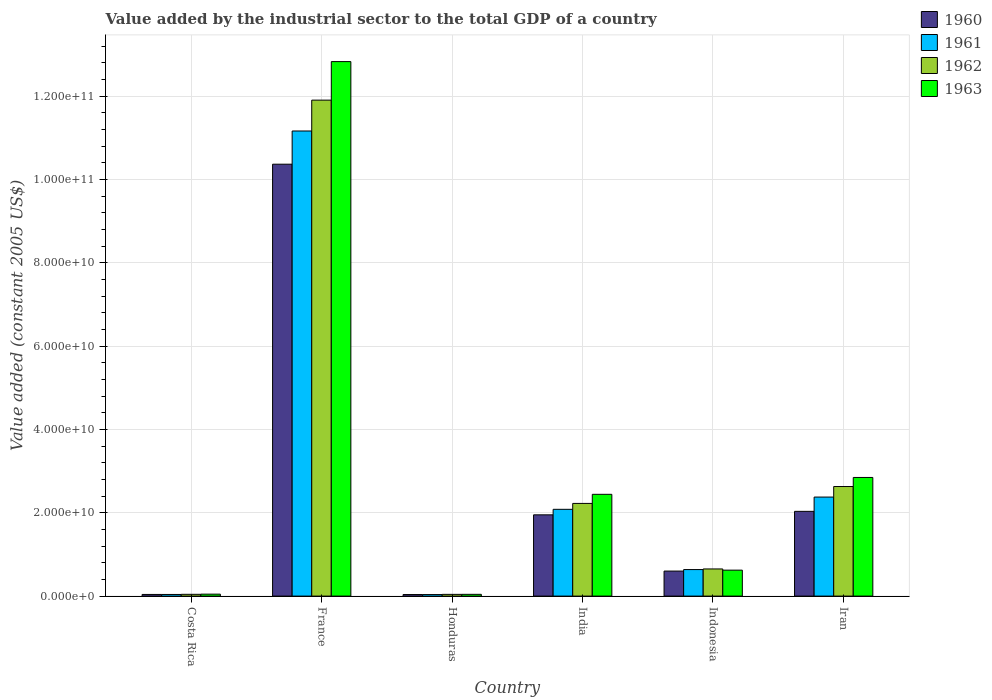How many groups of bars are there?
Make the answer very short. 6. Are the number of bars on each tick of the X-axis equal?
Keep it short and to the point. Yes. How many bars are there on the 6th tick from the left?
Your answer should be very brief. 4. What is the label of the 3rd group of bars from the left?
Give a very brief answer. Honduras. In how many cases, is the number of bars for a given country not equal to the number of legend labels?
Provide a succinct answer. 0. What is the value added by the industrial sector in 1961 in Honduras?
Offer a terse response. 3.66e+08. Across all countries, what is the maximum value added by the industrial sector in 1961?
Your answer should be very brief. 1.12e+11. Across all countries, what is the minimum value added by the industrial sector in 1960?
Ensure brevity in your answer.  3.75e+08. In which country was the value added by the industrial sector in 1963 minimum?
Provide a short and direct response. Honduras. What is the total value added by the industrial sector in 1963 in the graph?
Offer a terse response. 1.88e+11. What is the difference between the value added by the industrial sector in 1960 in Indonesia and that in Iran?
Ensure brevity in your answer.  -1.43e+1. What is the difference between the value added by the industrial sector in 1961 in Indonesia and the value added by the industrial sector in 1960 in Iran?
Provide a short and direct response. -1.40e+1. What is the average value added by the industrial sector in 1962 per country?
Your answer should be compact. 2.92e+1. What is the difference between the value added by the industrial sector of/in 1963 and value added by the industrial sector of/in 1961 in Indonesia?
Make the answer very short. -1.38e+08. In how many countries, is the value added by the industrial sector in 1960 greater than 112000000000 US$?
Your answer should be compact. 0. What is the ratio of the value added by the industrial sector in 1962 in India to that in Indonesia?
Provide a short and direct response. 3.41. Is the difference between the value added by the industrial sector in 1963 in Honduras and India greater than the difference between the value added by the industrial sector in 1961 in Honduras and India?
Your answer should be compact. No. What is the difference between the highest and the second highest value added by the industrial sector in 1961?
Your answer should be very brief. -2.94e+09. What is the difference between the highest and the lowest value added by the industrial sector in 1963?
Ensure brevity in your answer.  1.28e+11. In how many countries, is the value added by the industrial sector in 1963 greater than the average value added by the industrial sector in 1963 taken over all countries?
Offer a terse response. 1. Is the sum of the value added by the industrial sector in 1961 in Indonesia and Iran greater than the maximum value added by the industrial sector in 1960 across all countries?
Give a very brief answer. No. Is it the case that in every country, the sum of the value added by the industrial sector in 1960 and value added by the industrial sector in 1961 is greater than the sum of value added by the industrial sector in 1962 and value added by the industrial sector in 1963?
Your response must be concise. No. What does the 2nd bar from the left in Indonesia represents?
Provide a succinct answer. 1961. What does the 2nd bar from the right in Costa Rica represents?
Your response must be concise. 1962. Are all the bars in the graph horizontal?
Offer a terse response. No. How many countries are there in the graph?
Your answer should be very brief. 6. Does the graph contain any zero values?
Your answer should be compact. No. How many legend labels are there?
Provide a short and direct response. 4. What is the title of the graph?
Make the answer very short. Value added by the industrial sector to the total GDP of a country. What is the label or title of the Y-axis?
Offer a very short reply. Value added (constant 2005 US$). What is the Value added (constant 2005 US$) in 1960 in Costa Rica?
Your answer should be very brief. 3.98e+08. What is the Value added (constant 2005 US$) of 1961 in Costa Rica?
Provide a short and direct response. 3.94e+08. What is the Value added (constant 2005 US$) of 1962 in Costa Rica?
Ensure brevity in your answer.  4.27e+08. What is the Value added (constant 2005 US$) in 1963 in Costa Rica?
Your response must be concise. 4.68e+08. What is the Value added (constant 2005 US$) of 1960 in France?
Provide a short and direct response. 1.04e+11. What is the Value added (constant 2005 US$) of 1961 in France?
Your response must be concise. 1.12e+11. What is the Value added (constant 2005 US$) of 1962 in France?
Offer a terse response. 1.19e+11. What is the Value added (constant 2005 US$) of 1963 in France?
Make the answer very short. 1.28e+11. What is the Value added (constant 2005 US$) of 1960 in Honduras?
Your answer should be very brief. 3.75e+08. What is the Value added (constant 2005 US$) in 1961 in Honduras?
Ensure brevity in your answer.  3.66e+08. What is the Value added (constant 2005 US$) in 1962 in Honduras?
Offer a very short reply. 4.16e+08. What is the Value added (constant 2005 US$) of 1963 in Honduras?
Offer a very short reply. 4.23e+08. What is the Value added (constant 2005 US$) in 1960 in India?
Give a very brief answer. 1.95e+1. What is the Value added (constant 2005 US$) in 1961 in India?
Keep it short and to the point. 2.08e+1. What is the Value added (constant 2005 US$) in 1962 in India?
Your answer should be very brief. 2.22e+1. What is the Value added (constant 2005 US$) of 1963 in India?
Keep it short and to the point. 2.44e+1. What is the Value added (constant 2005 US$) of 1960 in Indonesia?
Offer a terse response. 6.01e+09. What is the Value added (constant 2005 US$) of 1961 in Indonesia?
Your answer should be very brief. 6.37e+09. What is the Value added (constant 2005 US$) of 1962 in Indonesia?
Provide a short and direct response. 6.52e+09. What is the Value added (constant 2005 US$) in 1963 in Indonesia?
Provide a short and direct response. 6.23e+09. What is the Value added (constant 2005 US$) in 1960 in Iran?
Keep it short and to the point. 2.03e+1. What is the Value added (constant 2005 US$) in 1961 in Iran?
Your answer should be very brief. 2.38e+1. What is the Value added (constant 2005 US$) of 1962 in Iran?
Offer a terse response. 2.63e+1. What is the Value added (constant 2005 US$) in 1963 in Iran?
Your answer should be compact. 2.85e+1. Across all countries, what is the maximum Value added (constant 2005 US$) in 1960?
Keep it short and to the point. 1.04e+11. Across all countries, what is the maximum Value added (constant 2005 US$) in 1961?
Provide a succinct answer. 1.12e+11. Across all countries, what is the maximum Value added (constant 2005 US$) in 1962?
Give a very brief answer. 1.19e+11. Across all countries, what is the maximum Value added (constant 2005 US$) of 1963?
Provide a succinct answer. 1.28e+11. Across all countries, what is the minimum Value added (constant 2005 US$) in 1960?
Provide a short and direct response. 3.75e+08. Across all countries, what is the minimum Value added (constant 2005 US$) of 1961?
Offer a terse response. 3.66e+08. Across all countries, what is the minimum Value added (constant 2005 US$) of 1962?
Your response must be concise. 4.16e+08. Across all countries, what is the minimum Value added (constant 2005 US$) of 1963?
Give a very brief answer. 4.23e+08. What is the total Value added (constant 2005 US$) in 1960 in the graph?
Give a very brief answer. 1.50e+11. What is the total Value added (constant 2005 US$) of 1961 in the graph?
Provide a short and direct response. 1.63e+11. What is the total Value added (constant 2005 US$) of 1962 in the graph?
Keep it short and to the point. 1.75e+11. What is the total Value added (constant 2005 US$) of 1963 in the graph?
Your response must be concise. 1.88e+11. What is the difference between the Value added (constant 2005 US$) in 1960 in Costa Rica and that in France?
Make the answer very short. -1.03e+11. What is the difference between the Value added (constant 2005 US$) in 1961 in Costa Rica and that in France?
Your answer should be very brief. -1.11e+11. What is the difference between the Value added (constant 2005 US$) of 1962 in Costa Rica and that in France?
Your answer should be compact. -1.19e+11. What is the difference between the Value added (constant 2005 US$) of 1963 in Costa Rica and that in France?
Make the answer very short. -1.28e+11. What is the difference between the Value added (constant 2005 US$) of 1960 in Costa Rica and that in Honduras?
Ensure brevity in your answer.  2.26e+07. What is the difference between the Value added (constant 2005 US$) in 1961 in Costa Rica and that in Honduras?
Your answer should be compact. 2.78e+07. What is the difference between the Value added (constant 2005 US$) of 1962 in Costa Rica and that in Honduras?
Keep it short and to the point. 1.10e+07. What is the difference between the Value added (constant 2005 US$) in 1963 in Costa Rica and that in Honduras?
Your answer should be compact. 4.49e+07. What is the difference between the Value added (constant 2005 US$) in 1960 in Costa Rica and that in India?
Give a very brief answer. -1.91e+1. What is the difference between the Value added (constant 2005 US$) in 1961 in Costa Rica and that in India?
Ensure brevity in your answer.  -2.04e+1. What is the difference between the Value added (constant 2005 US$) of 1962 in Costa Rica and that in India?
Provide a succinct answer. -2.18e+1. What is the difference between the Value added (constant 2005 US$) of 1963 in Costa Rica and that in India?
Your answer should be compact. -2.40e+1. What is the difference between the Value added (constant 2005 US$) of 1960 in Costa Rica and that in Indonesia?
Your answer should be compact. -5.61e+09. What is the difference between the Value added (constant 2005 US$) in 1961 in Costa Rica and that in Indonesia?
Your answer should be very brief. -5.97e+09. What is the difference between the Value added (constant 2005 US$) of 1962 in Costa Rica and that in Indonesia?
Provide a succinct answer. -6.09e+09. What is the difference between the Value added (constant 2005 US$) in 1963 in Costa Rica and that in Indonesia?
Your answer should be compact. -5.76e+09. What is the difference between the Value added (constant 2005 US$) in 1960 in Costa Rica and that in Iran?
Ensure brevity in your answer.  -1.99e+1. What is the difference between the Value added (constant 2005 US$) of 1961 in Costa Rica and that in Iran?
Make the answer very short. -2.34e+1. What is the difference between the Value added (constant 2005 US$) in 1962 in Costa Rica and that in Iran?
Make the answer very short. -2.59e+1. What is the difference between the Value added (constant 2005 US$) in 1963 in Costa Rica and that in Iran?
Keep it short and to the point. -2.80e+1. What is the difference between the Value added (constant 2005 US$) in 1960 in France and that in Honduras?
Make the answer very short. 1.03e+11. What is the difference between the Value added (constant 2005 US$) of 1961 in France and that in Honduras?
Ensure brevity in your answer.  1.11e+11. What is the difference between the Value added (constant 2005 US$) in 1962 in France and that in Honduras?
Your response must be concise. 1.19e+11. What is the difference between the Value added (constant 2005 US$) of 1963 in France and that in Honduras?
Your answer should be very brief. 1.28e+11. What is the difference between the Value added (constant 2005 US$) in 1960 in France and that in India?
Give a very brief answer. 8.42e+1. What is the difference between the Value added (constant 2005 US$) of 1961 in France and that in India?
Offer a very short reply. 9.08e+1. What is the difference between the Value added (constant 2005 US$) of 1962 in France and that in India?
Give a very brief answer. 9.68e+1. What is the difference between the Value added (constant 2005 US$) in 1963 in France and that in India?
Provide a short and direct response. 1.04e+11. What is the difference between the Value added (constant 2005 US$) in 1960 in France and that in Indonesia?
Offer a very short reply. 9.77e+1. What is the difference between the Value added (constant 2005 US$) of 1961 in France and that in Indonesia?
Provide a succinct answer. 1.05e+11. What is the difference between the Value added (constant 2005 US$) in 1962 in France and that in Indonesia?
Your answer should be compact. 1.13e+11. What is the difference between the Value added (constant 2005 US$) in 1963 in France and that in Indonesia?
Offer a terse response. 1.22e+11. What is the difference between the Value added (constant 2005 US$) of 1960 in France and that in Iran?
Your response must be concise. 8.33e+1. What is the difference between the Value added (constant 2005 US$) in 1961 in France and that in Iran?
Keep it short and to the point. 8.79e+1. What is the difference between the Value added (constant 2005 US$) of 1962 in France and that in Iran?
Keep it short and to the point. 9.27e+1. What is the difference between the Value added (constant 2005 US$) in 1963 in France and that in Iran?
Provide a short and direct response. 9.98e+1. What is the difference between the Value added (constant 2005 US$) of 1960 in Honduras and that in India?
Your answer should be compact. -1.91e+1. What is the difference between the Value added (constant 2005 US$) in 1961 in Honduras and that in India?
Offer a terse response. -2.05e+1. What is the difference between the Value added (constant 2005 US$) of 1962 in Honduras and that in India?
Offer a terse response. -2.18e+1. What is the difference between the Value added (constant 2005 US$) of 1963 in Honduras and that in India?
Keep it short and to the point. -2.40e+1. What is the difference between the Value added (constant 2005 US$) in 1960 in Honduras and that in Indonesia?
Make the answer very short. -5.63e+09. What is the difference between the Value added (constant 2005 US$) in 1961 in Honduras and that in Indonesia?
Your answer should be compact. -6.00e+09. What is the difference between the Value added (constant 2005 US$) of 1962 in Honduras and that in Indonesia?
Your answer should be compact. -6.10e+09. What is the difference between the Value added (constant 2005 US$) of 1963 in Honduras and that in Indonesia?
Your answer should be very brief. -5.81e+09. What is the difference between the Value added (constant 2005 US$) in 1960 in Honduras and that in Iran?
Offer a terse response. -2.00e+1. What is the difference between the Value added (constant 2005 US$) of 1961 in Honduras and that in Iran?
Keep it short and to the point. -2.34e+1. What is the difference between the Value added (constant 2005 US$) of 1962 in Honduras and that in Iran?
Offer a very short reply. -2.59e+1. What is the difference between the Value added (constant 2005 US$) of 1963 in Honduras and that in Iran?
Make the answer very short. -2.81e+1. What is the difference between the Value added (constant 2005 US$) of 1960 in India and that in Indonesia?
Keep it short and to the point. 1.35e+1. What is the difference between the Value added (constant 2005 US$) in 1961 in India and that in Indonesia?
Offer a terse response. 1.45e+1. What is the difference between the Value added (constant 2005 US$) in 1962 in India and that in Indonesia?
Your response must be concise. 1.57e+1. What is the difference between the Value added (constant 2005 US$) in 1963 in India and that in Indonesia?
Your answer should be very brief. 1.82e+1. What is the difference between the Value added (constant 2005 US$) in 1960 in India and that in Iran?
Give a very brief answer. -8.36e+08. What is the difference between the Value added (constant 2005 US$) of 1961 in India and that in Iran?
Offer a very short reply. -2.94e+09. What is the difference between the Value added (constant 2005 US$) in 1962 in India and that in Iran?
Offer a very short reply. -4.06e+09. What is the difference between the Value added (constant 2005 US$) in 1963 in India and that in Iran?
Give a very brief answer. -4.05e+09. What is the difference between the Value added (constant 2005 US$) in 1960 in Indonesia and that in Iran?
Make the answer very short. -1.43e+1. What is the difference between the Value added (constant 2005 US$) in 1961 in Indonesia and that in Iran?
Ensure brevity in your answer.  -1.74e+1. What is the difference between the Value added (constant 2005 US$) in 1962 in Indonesia and that in Iran?
Your answer should be very brief. -1.98e+1. What is the difference between the Value added (constant 2005 US$) in 1963 in Indonesia and that in Iran?
Make the answer very short. -2.22e+1. What is the difference between the Value added (constant 2005 US$) of 1960 in Costa Rica and the Value added (constant 2005 US$) of 1961 in France?
Make the answer very short. -1.11e+11. What is the difference between the Value added (constant 2005 US$) of 1960 in Costa Rica and the Value added (constant 2005 US$) of 1962 in France?
Make the answer very short. -1.19e+11. What is the difference between the Value added (constant 2005 US$) in 1960 in Costa Rica and the Value added (constant 2005 US$) in 1963 in France?
Ensure brevity in your answer.  -1.28e+11. What is the difference between the Value added (constant 2005 US$) of 1961 in Costa Rica and the Value added (constant 2005 US$) of 1962 in France?
Give a very brief answer. -1.19e+11. What is the difference between the Value added (constant 2005 US$) in 1961 in Costa Rica and the Value added (constant 2005 US$) in 1963 in France?
Provide a short and direct response. -1.28e+11. What is the difference between the Value added (constant 2005 US$) in 1962 in Costa Rica and the Value added (constant 2005 US$) in 1963 in France?
Provide a short and direct response. -1.28e+11. What is the difference between the Value added (constant 2005 US$) of 1960 in Costa Rica and the Value added (constant 2005 US$) of 1961 in Honduras?
Give a very brief answer. 3.20e+07. What is the difference between the Value added (constant 2005 US$) in 1960 in Costa Rica and the Value added (constant 2005 US$) in 1962 in Honduras?
Provide a short and direct response. -1.81e+07. What is the difference between the Value added (constant 2005 US$) in 1960 in Costa Rica and the Value added (constant 2005 US$) in 1963 in Honduras?
Keep it short and to the point. -2.52e+07. What is the difference between the Value added (constant 2005 US$) of 1961 in Costa Rica and the Value added (constant 2005 US$) of 1962 in Honduras?
Ensure brevity in your answer.  -2.22e+07. What is the difference between the Value added (constant 2005 US$) of 1961 in Costa Rica and the Value added (constant 2005 US$) of 1963 in Honduras?
Offer a terse response. -2.94e+07. What is the difference between the Value added (constant 2005 US$) in 1962 in Costa Rica and the Value added (constant 2005 US$) in 1963 in Honduras?
Keep it short and to the point. 3.81e+06. What is the difference between the Value added (constant 2005 US$) of 1960 in Costa Rica and the Value added (constant 2005 US$) of 1961 in India?
Offer a very short reply. -2.04e+1. What is the difference between the Value added (constant 2005 US$) of 1960 in Costa Rica and the Value added (constant 2005 US$) of 1962 in India?
Give a very brief answer. -2.18e+1. What is the difference between the Value added (constant 2005 US$) in 1960 in Costa Rica and the Value added (constant 2005 US$) in 1963 in India?
Offer a terse response. -2.40e+1. What is the difference between the Value added (constant 2005 US$) in 1961 in Costa Rica and the Value added (constant 2005 US$) in 1962 in India?
Provide a short and direct response. -2.19e+1. What is the difference between the Value added (constant 2005 US$) in 1961 in Costa Rica and the Value added (constant 2005 US$) in 1963 in India?
Offer a terse response. -2.40e+1. What is the difference between the Value added (constant 2005 US$) of 1962 in Costa Rica and the Value added (constant 2005 US$) of 1963 in India?
Provide a succinct answer. -2.40e+1. What is the difference between the Value added (constant 2005 US$) in 1960 in Costa Rica and the Value added (constant 2005 US$) in 1961 in Indonesia?
Provide a short and direct response. -5.97e+09. What is the difference between the Value added (constant 2005 US$) of 1960 in Costa Rica and the Value added (constant 2005 US$) of 1962 in Indonesia?
Ensure brevity in your answer.  -6.12e+09. What is the difference between the Value added (constant 2005 US$) in 1960 in Costa Rica and the Value added (constant 2005 US$) in 1963 in Indonesia?
Make the answer very short. -5.83e+09. What is the difference between the Value added (constant 2005 US$) in 1961 in Costa Rica and the Value added (constant 2005 US$) in 1962 in Indonesia?
Give a very brief answer. -6.12e+09. What is the difference between the Value added (constant 2005 US$) in 1961 in Costa Rica and the Value added (constant 2005 US$) in 1963 in Indonesia?
Ensure brevity in your answer.  -5.84e+09. What is the difference between the Value added (constant 2005 US$) in 1962 in Costa Rica and the Value added (constant 2005 US$) in 1963 in Indonesia?
Offer a terse response. -5.80e+09. What is the difference between the Value added (constant 2005 US$) in 1960 in Costa Rica and the Value added (constant 2005 US$) in 1961 in Iran?
Offer a terse response. -2.34e+1. What is the difference between the Value added (constant 2005 US$) of 1960 in Costa Rica and the Value added (constant 2005 US$) of 1962 in Iran?
Provide a short and direct response. -2.59e+1. What is the difference between the Value added (constant 2005 US$) of 1960 in Costa Rica and the Value added (constant 2005 US$) of 1963 in Iran?
Offer a very short reply. -2.81e+1. What is the difference between the Value added (constant 2005 US$) of 1961 in Costa Rica and the Value added (constant 2005 US$) of 1962 in Iran?
Your answer should be compact. -2.59e+1. What is the difference between the Value added (constant 2005 US$) in 1961 in Costa Rica and the Value added (constant 2005 US$) in 1963 in Iran?
Ensure brevity in your answer.  -2.81e+1. What is the difference between the Value added (constant 2005 US$) of 1962 in Costa Rica and the Value added (constant 2005 US$) of 1963 in Iran?
Your answer should be compact. -2.80e+1. What is the difference between the Value added (constant 2005 US$) in 1960 in France and the Value added (constant 2005 US$) in 1961 in Honduras?
Your response must be concise. 1.03e+11. What is the difference between the Value added (constant 2005 US$) in 1960 in France and the Value added (constant 2005 US$) in 1962 in Honduras?
Your answer should be very brief. 1.03e+11. What is the difference between the Value added (constant 2005 US$) in 1960 in France and the Value added (constant 2005 US$) in 1963 in Honduras?
Keep it short and to the point. 1.03e+11. What is the difference between the Value added (constant 2005 US$) in 1961 in France and the Value added (constant 2005 US$) in 1962 in Honduras?
Offer a terse response. 1.11e+11. What is the difference between the Value added (constant 2005 US$) of 1961 in France and the Value added (constant 2005 US$) of 1963 in Honduras?
Your answer should be compact. 1.11e+11. What is the difference between the Value added (constant 2005 US$) in 1962 in France and the Value added (constant 2005 US$) in 1963 in Honduras?
Your response must be concise. 1.19e+11. What is the difference between the Value added (constant 2005 US$) of 1960 in France and the Value added (constant 2005 US$) of 1961 in India?
Provide a succinct answer. 8.28e+1. What is the difference between the Value added (constant 2005 US$) of 1960 in France and the Value added (constant 2005 US$) of 1962 in India?
Your response must be concise. 8.14e+1. What is the difference between the Value added (constant 2005 US$) in 1960 in France and the Value added (constant 2005 US$) in 1963 in India?
Provide a short and direct response. 7.92e+1. What is the difference between the Value added (constant 2005 US$) of 1961 in France and the Value added (constant 2005 US$) of 1962 in India?
Give a very brief answer. 8.94e+1. What is the difference between the Value added (constant 2005 US$) of 1961 in France and the Value added (constant 2005 US$) of 1963 in India?
Keep it short and to the point. 8.72e+1. What is the difference between the Value added (constant 2005 US$) in 1962 in France and the Value added (constant 2005 US$) in 1963 in India?
Provide a short and direct response. 9.46e+1. What is the difference between the Value added (constant 2005 US$) in 1960 in France and the Value added (constant 2005 US$) in 1961 in Indonesia?
Keep it short and to the point. 9.73e+1. What is the difference between the Value added (constant 2005 US$) of 1960 in France and the Value added (constant 2005 US$) of 1962 in Indonesia?
Offer a very short reply. 9.71e+1. What is the difference between the Value added (constant 2005 US$) of 1960 in France and the Value added (constant 2005 US$) of 1963 in Indonesia?
Make the answer very short. 9.74e+1. What is the difference between the Value added (constant 2005 US$) in 1961 in France and the Value added (constant 2005 US$) in 1962 in Indonesia?
Your answer should be compact. 1.05e+11. What is the difference between the Value added (constant 2005 US$) of 1961 in France and the Value added (constant 2005 US$) of 1963 in Indonesia?
Give a very brief answer. 1.05e+11. What is the difference between the Value added (constant 2005 US$) of 1962 in France and the Value added (constant 2005 US$) of 1963 in Indonesia?
Provide a succinct answer. 1.13e+11. What is the difference between the Value added (constant 2005 US$) of 1960 in France and the Value added (constant 2005 US$) of 1961 in Iran?
Offer a terse response. 7.99e+1. What is the difference between the Value added (constant 2005 US$) of 1960 in France and the Value added (constant 2005 US$) of 1962 in Iran?
Provide a succinct answer. 7.74e+1. What is the difference between the Value added (constant 2005 US$) of 1960 in France and the Value added (constant 2005 US$) of 1963 in Iran?
Your response must be concise. 7.52e+1. What is the difference between the Value added (constant 2005 US$) in 1961 in France and the Value added (constant 2005 US$) in 1962 in Iran?
Make the answer very short. 8.53e+1. What is the difference between the Value added (constant 2005 US$) of 1961 in France and the Value added (constant 2005 US$) of 1963 in Iran?
Give a very brief answer. 8.32e+1. What is the difference between the Value added (constant 2005 US$) of 1962 in France and the Value added (constant 2005 US$) of 1963 in Iran?
Provide a succinct answer. 9.06e+1. What is the difference between the Value added (constant 2005 US$) in 1960 in Honduras and the Value added (constant 2005 US$) in 1961 in India?
Offer a very short reply. -2.05e+1. What is the difference between the Value added (constant 2005 US$) in 1960 in Honduras and the Value added (constant 2005 US$) in 1962 in India?
Keep it short and to the point. -2.19e+1. What is the difference between the Value added (constant 2005 US$) of 1960 in Honduras and the Value added (constant 2005 US$) of 1963 in India?
Offer a terse response. -2.41e+1. What is the difference between the Value added (constant 2005 US$) of 1961 in Honduras and the Value added (constant 2005 US$) of 1962 in India?
Provide a short and direct response. -2.19e+1. What is the difference between the Value added (constant 2005 US$) in 1961 in Honduras and the Value added (constant 2005 US$) in 1963 in India?
Your answer should be very brief. -2.41e+1. What is the difference between the Value added (constant 2005 US$) in 1962 in Honduras and the Value added (constant 2005 US$) in 1963 in India?
Ensure brevity in your answer.  -2.40e+1. What is the difference between the Value added (constant 2005 US$) in 1960 in Honduras and the Value added (constant 2005 US$) in 1961 in Indonesia?
Keep it short and to the point. -5.99e+09. What is the difference between the Value added (constant 2005 US$) of 1960 in Honduras and the Value added (constant 2005 US$) of 1962 in Indonesia?
Your answer should be compact. -6.14e+09. What is the difference between the Value added (constant 2005 US$) in 1960 in Honduras and the Value added (constant 2005 US$) in 1963 in Indonesia?
Your response must be concise. -5.85e+09. What is the difference between the Value added (constant 2005 US$) of 1961 in Honduras and the Value added (constant 2005 US$) of 1962 in Indonesia?
Your answer should be compact. -6.15e+09. What is the difference between the Value added (constant 2005 US$) in 1961 in Honduras and the Value added (constant 2005 US$) in 1963 in Indonesia?
Keep it short and to the point. -5.86e+09. What is the difference between the Value added (constant 2005 US$) of 1962 in Honduras and the Value added (constant 2005 US$) of 1963 in Indonesia?
Your response must be concise. -5.81e+09. What is the difference between the Value added (constant 2005 US$) in 1960 in Honduras and the Value added (constant 2005 US$) in 1961 in Iran?
Offer a terse response. -2.34e+1. What is the difference between the Value added (constant 2005 US$) in 1960 in Honduras and the Value added (constant 2005 US$) in 1962 in Iran?
Your answer should be compact. -2.59e+1. What is the difference between the Value added (constant 2005 US$) in 1960 in Honduras and the Value added (constant 2005 US$) in 1963 in Iran?
Your answer should be compact. -2.81e+1. What is the difference between the Value added (constant 2005 US$) in 1961 in Honduras and the Value added (constant 2005 US$) in 1962 in Iran?
Ensure brevity in your answer.  -2.59e+1. What is the difference between the Value added (constant 2005 US$) of 1961 in Honduras and the Value added (constant 2005 US$) of 1963 in Iran?
Offer a very short reply. -2.81e+1. What is the difference between the Value added (constant 2005 US$) of 1962 in Honduras and the Value added (constant 2005 US$) of 1963 in Iran?
Ensure brevity in your answer.  -2.81e+1. What is the difference between the Value added (constant 2005 US$) of 1960 in India and the Value added (constant 2005 US$) of 1961 in Indonesia?
Keep it short and to the point. 1.31e+1. What is the difference between the Value added (constant 2005 US$) in 1960 in India and the Value added (constant 2005 US$) in 1962 in Indonesia?
Give a very brief answer. 1.30e+1. What is the difference between the Value added (constant 2005 US$) in 1960 in India and the Value added (constant 2005 US$) in 1963 in Indonesia?
Provide a succinct answer. 1.33e+1. What is the difference between the Value added (constant 2005 US$) in 1961 in India and the Value added (constant 2005 US$) in 1962 in Indonesia?
Offer a very short reply. 1.43e+1. What is the difference between the Value added (constant 2005 US$) in 1961 in India and the Value added (constant 2005 US$) in 1963 in Indonesia?
Provide a succinct answer. 1.46e+1. What is the difference between the Value added (constant 2005 US$) of 1962 in India and the Value added (constant 2005 US$) of 1963 in Indonesia?
Make the answer very short. 1.60e+1. What is the difference between the Value added (constant 2005 US$) of 1960 in India and the Value added (constant 2005 US$) of 1961 in Iran?
Make the answer very short. -4.27e+09. What is the difference between the Value added (constant 2005 US$) in 1960 in India and the Value added (constant 2005 US$) in 1962 in Iran?
Keep it short and to the point. -6.80e+09. What is the difference between the Value added (constant 2005 US$) in 1960 in India and the Value added (constant 2005 US$) in 1963 in Iran?
Give a very brief answer. -8.97e+09. What is the difference between the Value added (constant 2005 US$) in 1961 in India and the Value added (constant 2005 US$) in 1962 in Iran?
Keep it short and to the point. -5.48e+09. What is the difference between the Value added (constant 2005 US$) of 1961 in India and the Value added (constant 2005 US$) of 1963 in Iran?
Offer a terse response. -7.65e+09. What is the difference between the Value added (constant 2005 US$) in 1962 in India and the Value added (constant 2005 US$) in 1963 in Iran?
Give a very brief answer. -6.23e+09. What is the difference between the Value added (constant 2005 US$) in 1960 in Indonesia and the Value added (constant 2005 US$) in 1961 in Iran?
Provide a short and direct response. -1.78e+1. What is the difference between the Value added (constant 2005 US$) of 1960 in Indonesia and the Value added (constant 2005 US$) of 1962 in Iran?
Make the answer very short. -2.03e+1. What is the difference between the Value added (constant 2005 US$) of 1960 in Indonesia and the Value added (constant 2005 US$) of 1963 in Iran?
Your response must be concise. -2.25e+1. What is the difference between the Value added (constant 2005 US$) of 1961 in Indonesia and the Value added (constant 2005 US$) of 1962 in Iran?
Your answer should be compact. -1.99e+1. What is the difference between the Value added (constant 2005 US$) of 1961 in Indonesia and the Value added (constant 2005 US$) of 1963 in Iran?
Keep it short and to the point. -2.21e+1. What is the difference between the Value added (constant 2005 US$) of 1962 in Indonesia and the Value added (constant 2005 US$) of 1963 in Iran?
Offer a very short reply. -2.20e+1. What is the average Value added (constant 2005 US$) in 1960 per country?
Provide a short and direct response. 2.50e+1. What is the average Value added (constant 2005 US$) of 1961 per country?
Make the answer very short. 2.72e+1. What is the average Value added (constant 2005 US$) in 1962 per country?
Keep it short and to the point. 2.92e+1. What is the average Value added (constant 2005 US$) of 1963 per country?
Your answer should be very brief. 3.14e+1. What is the difference between the Value added (constant 2005 US$) of 1960 and Value added (constant 2005 US$) of 1961 in Costa Rica?
Give a very brief answer. 4.19e+06. What is the difference between the Value added (constant 2005 US$) in 1960 and Value added (constant 2005 US$) in 1962 in Costa Rica?
Make the answer very short. -2.91e+07. What is the difference between the Value added (constant 2005 US$) in 1960 and Value added (constant 2005 US$) in 1963 in Costa Rica?
Your response must be concise. -7.01e+07. What is the difference between the Value added (constant 2005 US$) in 1961 and Value added (constant 2005 US$) in 1962 in Costa Rica?
Make the answer very short. -3.32e+07. What is the difference between the Value added (constant 2005 US$) of 1961 and Value added (constant 2005 US$) of 1963 in Costa Rica?
Keep it short and to the point. -7.43e+07. What is the difference between the Value added (constant 2005 US$) in 1962 and Value added (constant 2005 US$) in 1963 in Costa Rica?
Keep it short and to the point. -4.11e+07. What is the difference between the Value added (constant 2005 US$) in 1960 and Value added (constant 2005 US$) in 1961 in France?
Your answer should be compact. -7.97e+09. What is the difference between the Value added (constant 2005 US$) of 1960 and Value added (constant 2005 US$) of 1962 in France?
Ensure brevity in your answer.  -1.54e+1. What is the difference between the Value added (constant 2005 US$) of 1960 and Value added (constant 2005 US$) of 1963 in France?
Make the answer very short. -2.46e+1. What is the difference between the Value added (constant 2005 US$) in 1961 and Value added (constant 2005 US$) in 1962 in France?
Offer a very short reply. -7.41e+09. What is the difference between the Value added (constant 2005 US$) of 1961 and Value added (constant 2005 US$) of 1963 in France?
Offer a very short reply. -1.67e+1. What is the difference between the Value added (constant 2005 US$) of 1962 and Value added (constant 2005 US$) of 1963 in France?
Offer a terse response. -9.25e+09. What is the difference between the Value added (constant 2005 US$) of 1960 and Value added (constant 2005 US$) of 1961 in Honduras?
Offer a very short reply. 9.37e+06. What is the difference between the Value added (constant 2005 US$) in 1960 and Value added (constant 2005 US$) in 1962 in Honduras?
Your answer should be compact. -4.07e+07. What is the difference between the Value added (constant 2005 US$) of 1960 and Value added (constant 2005 US$) of 1963 in Honduras?
Your answer should be compact. -4.79e+07. What is the difference between the Value added (constant 2005 US$) in 1961 and Value added (constant 2005 US$) in 1962 in Honduras?
Your response must be concise. -5.00e+07. What is the difference between the Value added (constant 2005 US$) of 1961 and Value added (constant 2005 US$) of 1963 in Honduras?
Keep it short and to the point. -5.72e+07. What is the difference between the Value added (constant 2005 US$) in 1962 and Value added (constant 2005 US$) in 1963 in Honduras?
Provide a succinct answer. -7.19e+06. What is the difference between the Value added (constant 2005 US$) in 1960 and Value added (constant 2005 US$) in 1961 in India?
Your answer should be very brief. -1.32e+09. What is the difference between the Value added (constant 2005 US$) in 1960 and Value added (constant 2005 US$) in 1962 in India?
Provide a short and direct response. -2.74e+09. What is the difference between the Value added (constant 2005 US$) in 1960 and Value added (constant 2005 US$) in 1963 in India?
Your answer should be compact. -4.92e+09. What is the difference between the Value added (constant 2005 US$) in 1961 and Value added (constant 2005 US$) in 1962 in India?
Provide a short and direct response. -1.42e+09. What is the difference between the Value added (constant 2005 US$) of 1961 and Value added (constant 2005 US$) of 1963 in India?
Keep it short and to the point. -3.60e+09. What is the difference between the Value added (constant 2005 US$) in 1962 and Value added (constant 2005 US$) in 1963 in India?
Ensure brevity in your answer.  -2.18e+09. What is the difference between the Value added (constant 2005 US$) of 1960 and Value added (constant 2005 US$) of 1961 in Indonesia?
Offer a terse response. -3.60e+08. What is the difference between the Value added (constant 2005 US$) in 1960 and Value added (constant 2005 US$) in 1962 in Indonesia?
Ensure brevity in your answer.  -5.10e+08. What is the difference between the Value added (constant 2005 US$) in 1960 and Value added (constant 2005 US$) in 1963 in Indonesia?
Your response must be concise. -2.22e+08. What is the difference between the Value added (constant 2005 US$) in 1961 and Value added (constant 2005 US$) in 1962 in Indonesia?
Ensure brevity in your answer.  -1.50e+08. What is the difference between the Value added (constant 2005 US$) in 1961 and Value added (constant 2005 US$) in 1963 in Indonesia?
Provide a short and direct response. 1.38e+08. What is the difference between the Value added (constant 2005 US$) of 1962 and Value added (constant 2005 US$) of 1963 in Indonesia?
Give a very brief answer. 2.88e+08. What is the difference between the Value added (constant 2005 US$) of 1960 and Value added (constant 2005 US$) of 1961 in Iran?
Give a very brief answer. -3.43e+09. What is the difference between the Value added (constant 2005 US$) of 1960 and Value added (constant 2005 US$) of 1962 in Iran?
Provide a short and direct response. -5.96e+09. What is the difference between the Value added (constant 2005 US$) in 1960 and Value added (constant 2005 US$) in 1963 in Iran?
Keep it short and to the point. -8.14e+09. What is the difference between the Value added (constant 2005 US$) in 1961 and Value added (constant 2005 US$) in 1962 in Iran?
Offer a terse response. -2.53e+09. What is the difference between the Value added (constant 2005 US$) of 1961 and Value added (constant 2005 US$) of 1963 in Iran?
Keep it short and to the point. -4.71e+09. What is the difference between the Value added (constant 2005 US$) in 1962 and Value added (constant 2005 US$) in 1963 in Iran?
Your answer should be compact. -2.17e+09. What is the ratio of the Value added (constant 2005 US$) in 1960 in Costa Rica to that in France?
Offer a terse response. 0. What is the ratio of the Value added (constant 2005 US$) of 1961 in Costa Rica to that in France?
Offer a terse response. 0. What is the ratio of the Value added (constant 2005 US$) in 1962 in Costa Rica to that in France?
Give a very brief answer. 0. What is the ratio of the Value added (constant 2005 US$) in 1963 in Costa Rica to that in France?
Make the answer very short. 0. What is the ratio of the Value added (constant 2005 US$) of 1960 in Costa Rica to that in Honduras?
Provide a short and direct response. 1.06. What is the ratio of the Value added (constant 2005 US$) in 1961 in Costa Rica to that in Honduras?
Your response must be concise. 1.08. What is the ratio of the Value added (constant 2005 US$) of 1962 in Costa Rica to that in Honduras?
Keep it short and to the point. 1.03. What is the ratio of the Value added (constant 2005 US$) of 1963 in Costa Rica to that in Honduras?
Your response must be concise. 1.11. What is the ratio of the Value added (constant 2005 US$) of 1960 in Costa Rica to that in India?
Provide a succinct answer. 0.02. What is the ratio of the Value added (constant 2005 US$) in 1961 in Costa Rica to that in India?
Your answer should be compact. 0.02. What is the ratio of the Value added (constant 2005 US$) in 1962 in Costa Rica to that in India?
Your response must be concise. 0.02. What is the ratio of the Value added (constant 2005 US$) in 1963 in Costa Rica to that in India?
Give a very brief answer. 0.02. What is the ratio of the Value added (constant 2005 US$) of 1960 in Costa Rica to that in Indonesia?
Give a very brief answer. 0.07. What is the ratio of the Value added (constant 2005 US$) in 1961 in Costa Rica to that in Indonesia?
Your answer should be compact. 0.06. What is the ratio of the Value added (constant 2005 US$) of 1962 in Costa Rica to that in Indonesia?
Provide a short and direct response. 0.07. What is the ratio of the Value added (constant 2005 US$) in 1963 in Costa Rica to that in Indonesia?
Your answer should be compact. 0.08. What is the ratio of the Value added (constant 2005 US$) of 1960 in Costa Rica to that in Iran?
Provide a succinct answer. 0.02. What is the ratio of the Value added (constant 2005 US$) in 1961 in Costa Rica to that in Iran?
Keep it short and to the point. 0.02. What is the ratio of the Value added (constant 2005 US$) in 1962 in Costa Rica to that in Iran?
Ensure brevity in your answer.  0.02. What is the ratio of the Value added (constant 2005 US$) in 1963 in Costa Rica to that in Iran?
Your answer should be compact. 0.02. What is the ratio of the Value added (constant 2005 US$) of 1960 in France to that in Honduras?
Keep it short and to the point. 276.31. What is the ratio of the Value added (constant 2005 US$) in 1961 in France to that in Honduras?
Provide a succinct answer. 305.16. What is the ratio of the Value added (constant 2005 US$) of 1962 in France to that in Honduras?
Provide a short and direct response. 286.26. What is the ratio of the Value added (constant 2005 US$) in 1963 in France to that in Honduras?
Give a very brief answer. 303.25. What is the ratio of the Value added (constant 2005 US$) in 1960 in France to that in India?
Provide a short and direct response. 5.32. What is the ratio of the Value added (constant 2005 US$) in 1961 in France to that in India?
Give a very brief answer. 5.36. What is the ratio of the Value added (constant 2005 US$) of 1962 in France to that in India?
Your answer should be very brief. 5.35. What is the ratio of the Value added (constant 2005 US$) of 1963 in France to that in India?
Make the answer very short. 5.25. What is the ratio of the Value added (constant 2005 US$) of 1960 in France to that in Indonesia?
Your answer should be very brief. 17.26. What is the ratio of the Value added (constant 2005 US$) of 1961 in France to that in Indonesia?
Offer a terse response. 17.53. What is the ratio of the Value added (constant 2005 US$) in 1962 in France to that in Indonesia?
Keep it short and to the point. 18.27. What is the ratio of the Value added (constant 2005 US$) in 1963 in France to that in Indonesia?
Your answer should be compact. 20.59. What is the ratio of the Value added (constant 2005 US$) in 1960 in France to that in Iran?
Provide a succinct answer. 5.1. What is the ratio of the Value added (constant 2005 US$) in 1961 in France to that in Iran?
Provide a short and direct response. 4.7. What is the ratio of the Value added (constant 2005 US$) of 1962 in France to that in Iran?
Offer a very short reply. 4.53. What is the ratio of the Value added (constant 2005 US$) in 1963 in France to that in Iran?
Ensure brevity in your answer.  4.51. What is the ratio of the Value added (constant 2005 US$) in 1960 in Honduras to that in India?
Your answer should be very brief. 0.02. What is the ratio of the Value added (constant 2005 US$) of 1961 in Honduras to that in India?
Your response must be concise. 0.02. What is the ratio of the Value added (constant 2005 US$) in 1962 in Honduras to that in India?
Offer a terse response. 0.02. What is the ratio of the Value added (constant 2005 US$) in 1963 in Honduras to that in India?
Provide a short and direct response. 0.02. What is the ratio of the Value added (constant 2005 US$) of 1960 in Honduras to that in Indonesia?
Give a very brief answer. 0.06. What is the ratio of the Value added (constant 2005 US$) in 1961 in Honduras to that in Indonesia?
Provide a succinct answer. 0.06. What is the ratio of the Value added (constant 2005 US$) in 1962 in Honduras to that in Indonesia?
Make the answer very short. 0.06. What is the ratio of the Value added (constant 2005 US$) of 1963 in Honduras to that in Indonesia?
Ensure brevity in your answer.  0.07. What is the ratio of the Value added (constant 2005 US$) of 1960 in Honduras to that in Iran?
Keep it short and to the point. 0.02. What is the ratio of the Value added (constant 2005 US$) in 1961 in Honduras to that in Iran?
Provide a short and direct response. 0.02. What is the ratio of the Value added (constant 2005 US$) of 1962 in Honduras to that in Iran?
Your answer should be compact. 0.02. What is the ratio of the Value added (constant 2005 US$) in 1963 in Honduras to that in Iran?
Keep it short and to the point. 0.01. What is the ratio of the Value added (constant 2005 US$) of 1960 in India to that in Indonesia?
Keep it short and to the point. 3.25. What is the ratio of the Value added (constant 2005 US$) of 1961 in India to that in Indonesia?
Offer a terse response. 3.27. What is the ratio of the Value added (constant 2005 US$) of 1962 in India to that in Indonesia?
Your response must be concise. 3.41. What is the ratio of the Value added (constant 2005 US$) in 1963 in India to that in Indonesia?
Offer a very short reply. 3.92. What is the ratio of the Value added (constant 2005 US$) in 1960 in India to that in Iran?
Your response must be concise. 0.96. What is the ratio of the Value added (constant 2005 US$) in 1961 in India to that in Iran?
Keep it short and to the point. 0.88. What is the ratio of the Value added (constant 2005 US$) in 1962 in India to that in Iran?
Offer a very short reply. 0.85. What is the ratio of the Value added (constant 2005 US$) in 1963 in India to that in Iran?
Offer a terse response. 0.86. What is the ratio of the Value added (constant 2005 US$) in 1960 in Indonesia to that in Iran?
Your answer should be compact. 0.3. What is the ratio of the Value added (constant 2005 US$) in 1961 in Indonesia to that in Iran?
Keep it short and to the point. 0.27. What is the ratio of the Value added (constant 2005 US$) of 1962 in Indonesia to that in Iran?
Your answer should be very brief. 0.25. What is the ratio of the Value added (constant 2005 US$) in 1963 in Indonesia to that in Iran?
Provide a succinct answer. 0.22. What is the difference between the highest and the second highest Value added (constant 2005 US$) in 1960?
Your answer should be compact. 8.33e+1. What is the difference between the highest and the second highest Value added (constant 2005 US$) in 1961?
Your answer should be compact. 8.79e+1. What is the difference between the highest and the second highest Value added (constant 2005 US$) of 1962?
Make the answer very short. 9.27e+1. What is the difference between the highest and the second highest Value added (constant 2005 US$) in 1963?
Provide a succinct answer. 9.98e+1. What is the difference between the highest and the lowest Value added (constant 2005 US$) in 1960?
Provide a succinct answer. 1.03e+11. What is the difference between the highest and the lowest Value added (constant 2005 US$) of 1961?
Your answer should be very brief. 1.11e+11. What is the difference between the highest and the lowest Value added (constant 2005 US$) in 1962?
Keep it short and to the point. 1.19e+11. What is the difference between the highest and the lowest Value added (constant 2005 US$) of 1963?
Offer a very short reply. 1.28e+11. 